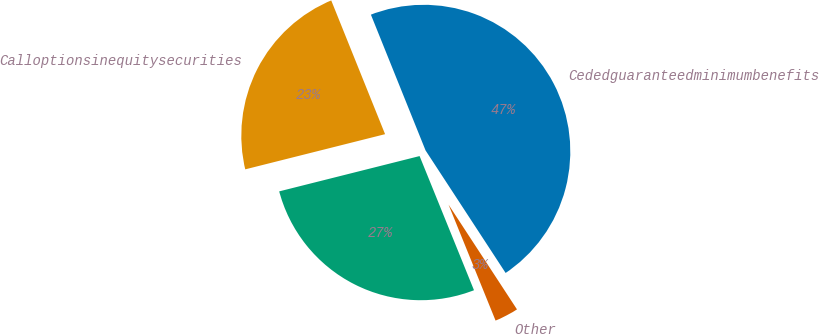Convert chart to OTSL. <chart><loc_0><loc_0><loc_500><loc_500><pie_chart><fcel>Cededguaranteedminimumbenefits<fcel>Calloptionsinequitysecurities<fcel>Unnamed: 2<fcel>Other<nl><fcel>46.88%<fcel>22.83%<fcel>27.21%<fcel>3.08%<nl></chart> 